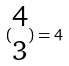<formula> <loc_0><loc_0><loc_500><loc_500>( \begin{matrix} 4 \\ 3 \end{matrix} ) = 4</formula> 